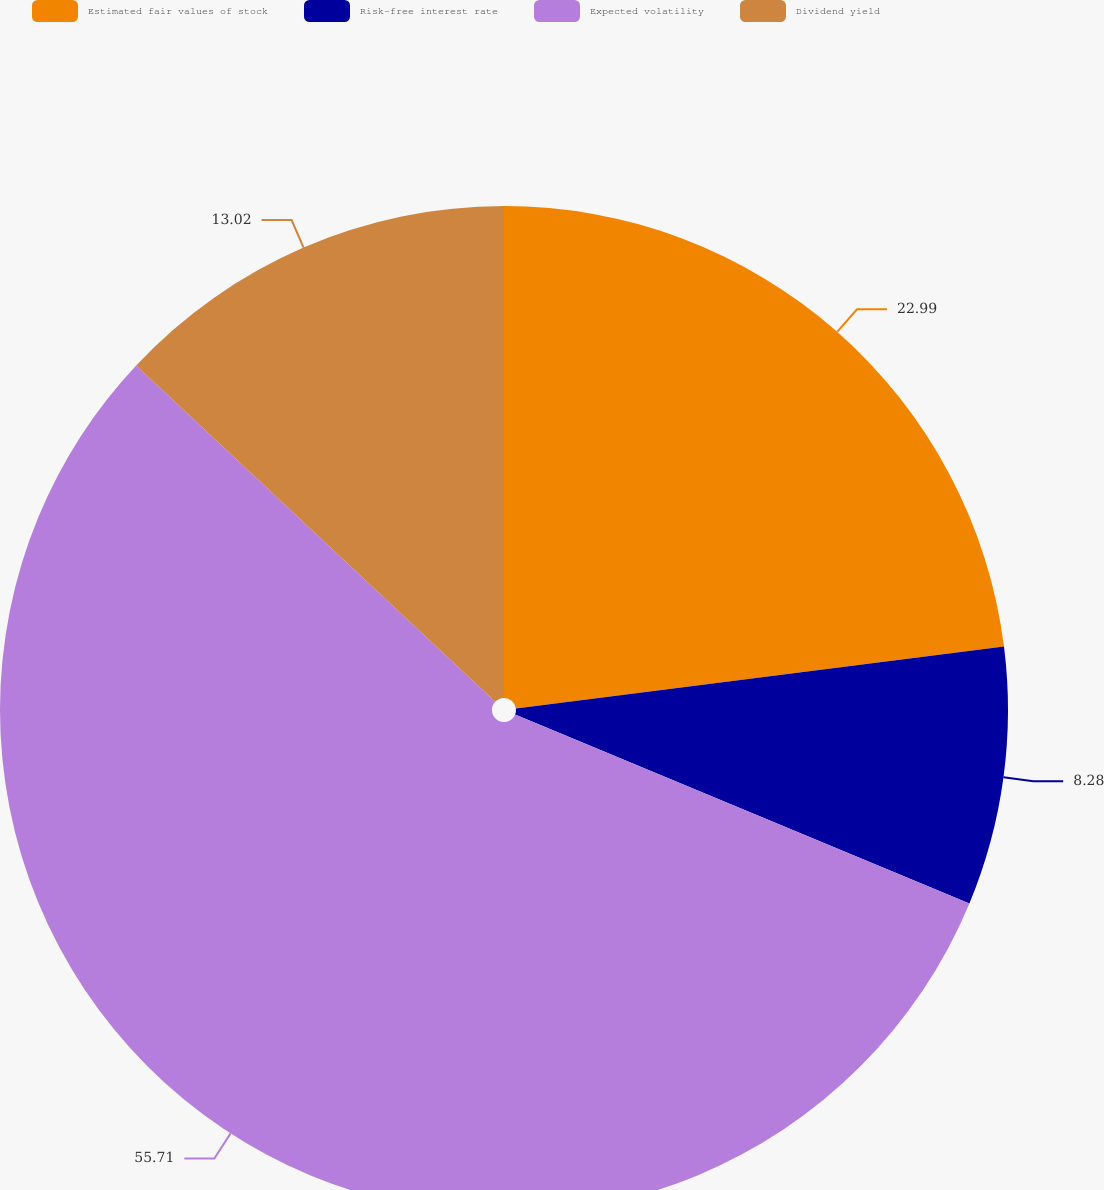<chart> <loc_0><loc_0><loc_500><loc_500><pie_chart><fcel>Estimated fair values of stock<fcel>Risk-free interest rate<fcel>Expected volatility<fcel>Dividend yield<nl><fcel>22.99%<fcel>8.28%<fcel>55.71%<fcel>13.02%<nl></chart> 